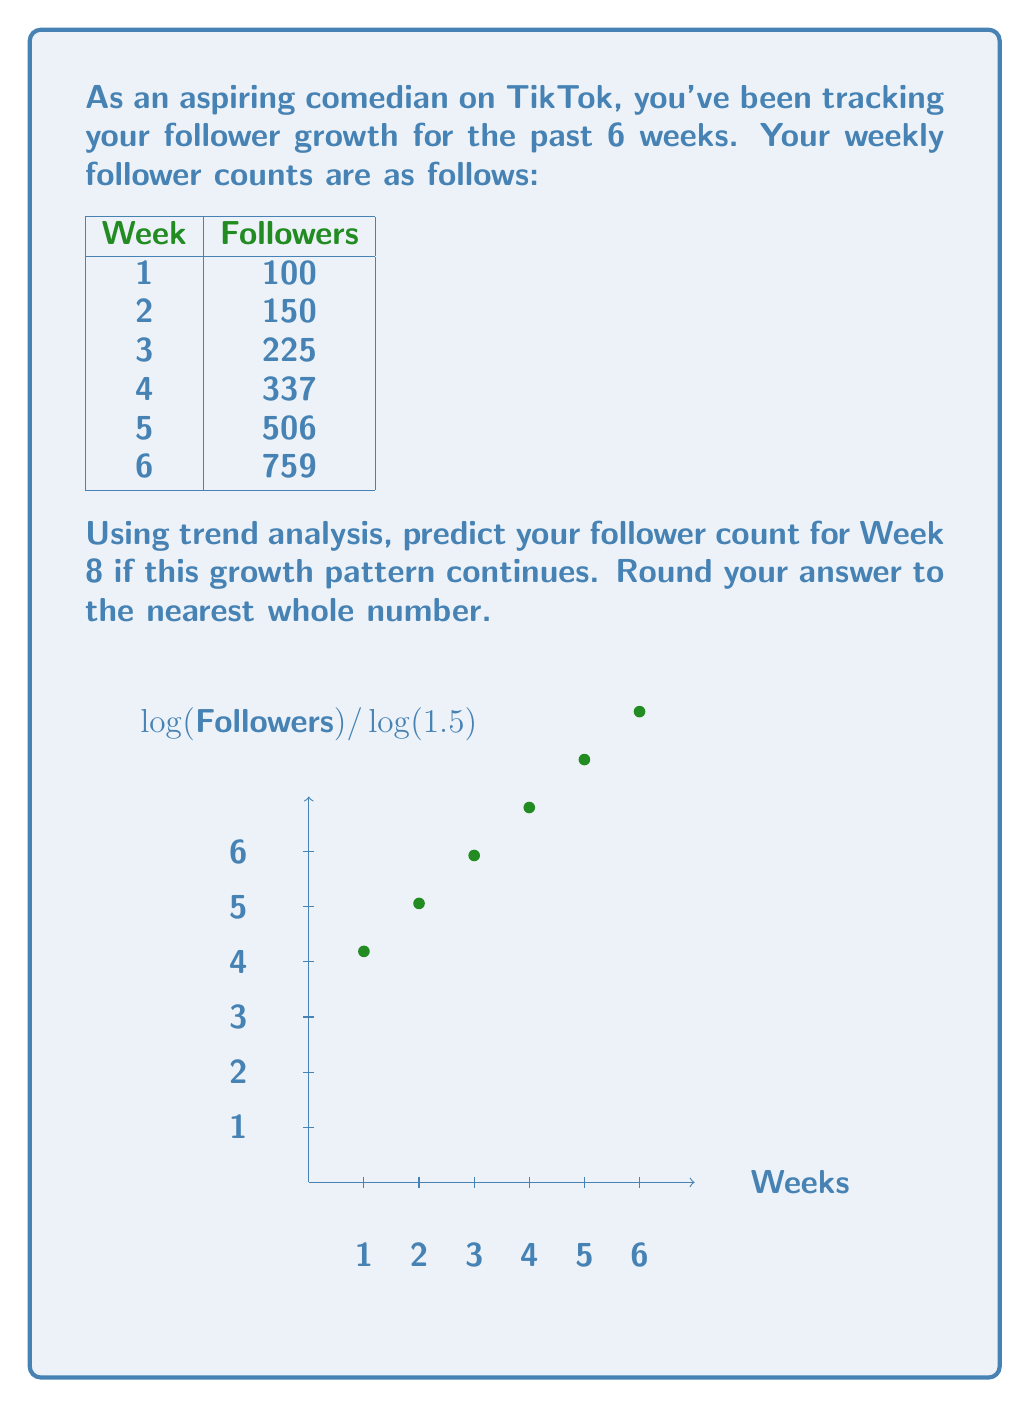Can you answer this question? To predict the growth rate, we'll use exponential trend analysis:

1) First, observe that the follower count is roughly multiplying by a constant factor each week. Let's call this factor $r$.

2) We can estimate $r$ by taking the geometric mean of the weekly growth rates:

   $$r = \sqrt[5]{\frac{150}{100} \cdot \frac{225}{150} \cdot \frac{337}{225} \cdot \frac{506}{337} \cdot \frac{759}{506}} \approx 1.5$$

3) This suggests our follower count follows the model:

   $$f(t) = 100 \cdot 1.5^{t-1}$$

   where $f(t)$ is the follower count and $t$ is the week number.

4) To predict Week 8, we plug in $t=8$:

   $$f(8) = 100 \cdot 1.5^{8-1} = 100 \cdot 1.5^7 \approx 1708.59$$

5) Rounding to the nearest whole number, we get 1709 followers.
Answer: 1709 followers 